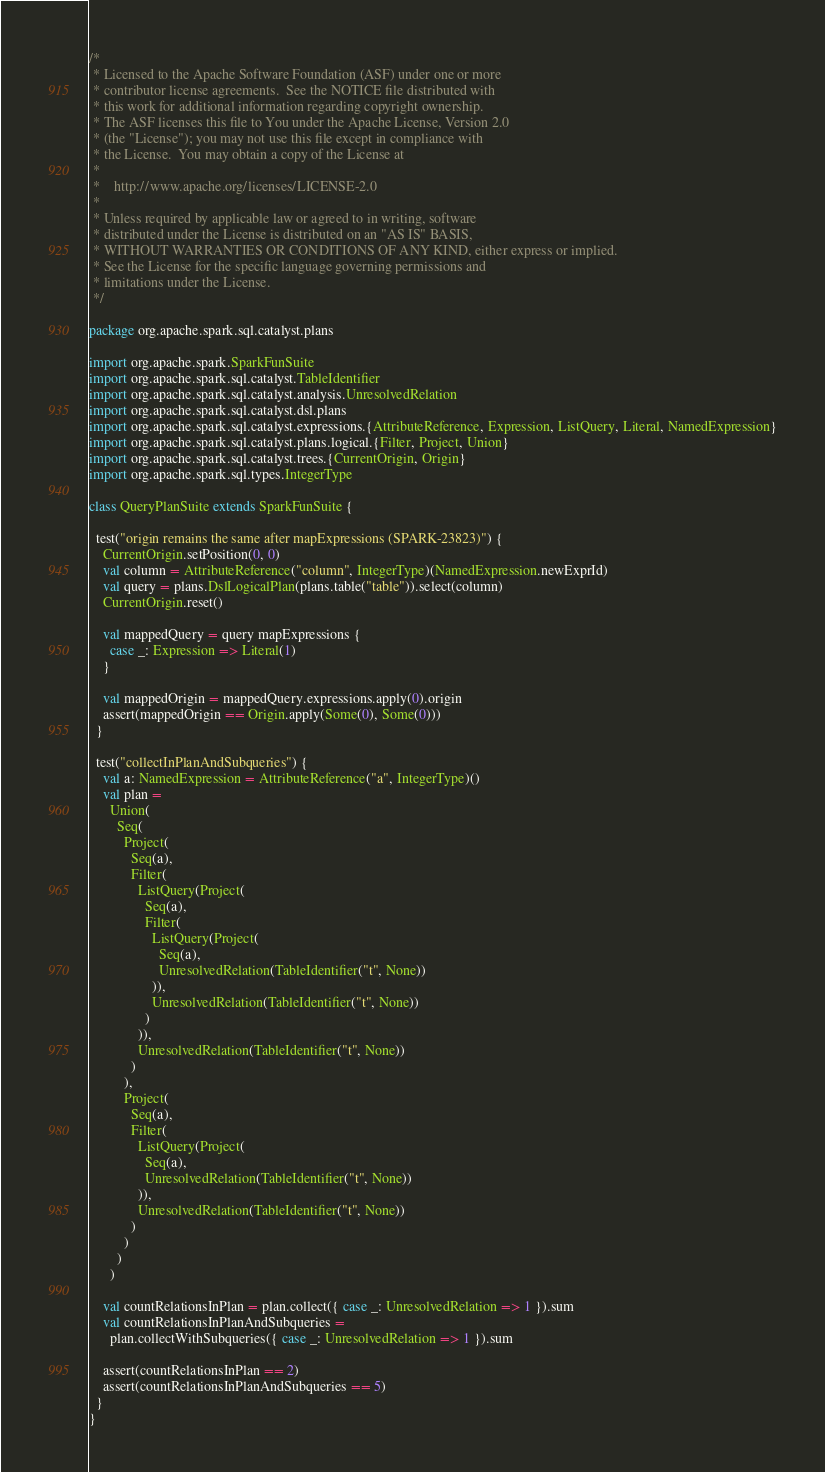Convert code to text. <code><loc_0><loc_0><loc_500><loc_500><_Scala_>/*
 * Licensed to the Apache Software Foundation (ASF) under one or more
 * contributor license agreements.  See the NOTICE file distributed with
 * this work for additional information regarding copyright ownership.
 * The ASF licenses this file to You under the Apache License, Version 2.0
 * (the "License"); you may not use this file except in compliance with
 * the License.  You may obtain a copy of the License at
 *
 *    http://www.apache.org/licenses/LICENSE-2.0
 *
 * Unless required by applicable law or agreed to in writing, software
 * distributed under the License is distributed on an "AS IS" BASIS,
 * WITHOUT WARRANTIES OR CONDITIONS OF ANY KIND, either express or implied.
 * See the License for the specific language governing permissions and
 * limitations under the License.
 */

package org.apache.spark.sql.catalyst.plans

import org.apache.spark.SparkFunSuite
import org.apache.spark.sql.catalyst.TableIdentifier
import org.apache.spark.sql.catalyst.analysis.UnresolvedRelation
import org.apache.spark.sql.catalyst.dsl.plans
import org.apache.spark.sql.catalyst.expressions.{AttributeReference, Expression, ListQuery, Literal, NamedExpression}
import org.apache.spark.sql.catalyst.plans.logical.{Filter, Project, Union}
import org.apache.spark.sql.catalyst.trees.{CurrentOrigin, Origin}
import org.apache.spark.sql.types.IntegerType

class QueryPlanSuite extends SparkFunSuite {

  test("origin remains the same after mapExpressions (SPARK-23823)") {
    CurrentOrigin.setPosition(0, 0)
    val column = AttributeReference("column", IntegerType)(NamedExpression.newExprId)
    val query = plans.DslLogicalPlan(plans.table("table")).select(column)
    CurrentOrigin.reset()

    val mappedQuery = query mapExpressions {
      case _: Expression => Literal(1)
    }

    val mappedOrigin = mappedQuery.expressions.apply(0).origin
    assert(mappedOrigin == Origin.apply(Some(0), Some(0)))
  }

  test("collectInPlanAndSubqueries") {
    val a: NamedExpression = AttributeReference("a", IntegerType)()
    val plan =
      Union(
        Seq(
          Project(
            Seq(a),
            Filter(
              ListQuery(Project(
                Seq(a),
                Filter(
                  ListQuery(Project(
                    Seq(a),
                    UnresolvedRelation(TableIdentifier("t", None))
                  )),
                  UnresolvedRelation(TableIdentifier("t", None))
                )
              )),
              UnresolvedRelation(TableIdentifier("t", None))
            )
          ),
          Project(
            Seq(a),
            Filter(
              ListQuery(Project(
                Seq(a),
                UnresolvedRelation(TableIdentifier("t", None))
              )),
              UnresolvedRelation(TableIdentifier("t", None))
            )
          )
        )
      )

    val countRelationsInPlan = plan.collect({ case _: UnresolvedRelation => 1 }).sum
    val countRelationsInPlanAndSubqueries =
      plan.collectWithSubqueries({ case _: UnresolvedRelation => 1 }).sum

    assert(countRelationsInPlan == 2)
    assert(countRelationsInPlanAndSubqueries == 5)
  }
}
</code> 